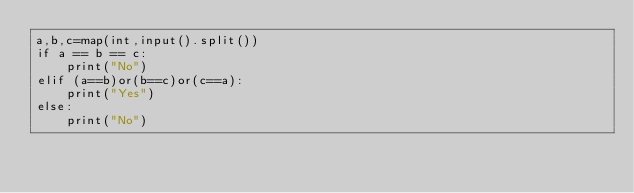<code> <loc_0><loc_0><loc_500><loc_500><_Python_>a,b,c=map(int,input().split())
if a == b == c:
    print("No")
elif (a==b)or(b==c)or(c==a):
    print("Yes")
else:
    print("No")</code> 